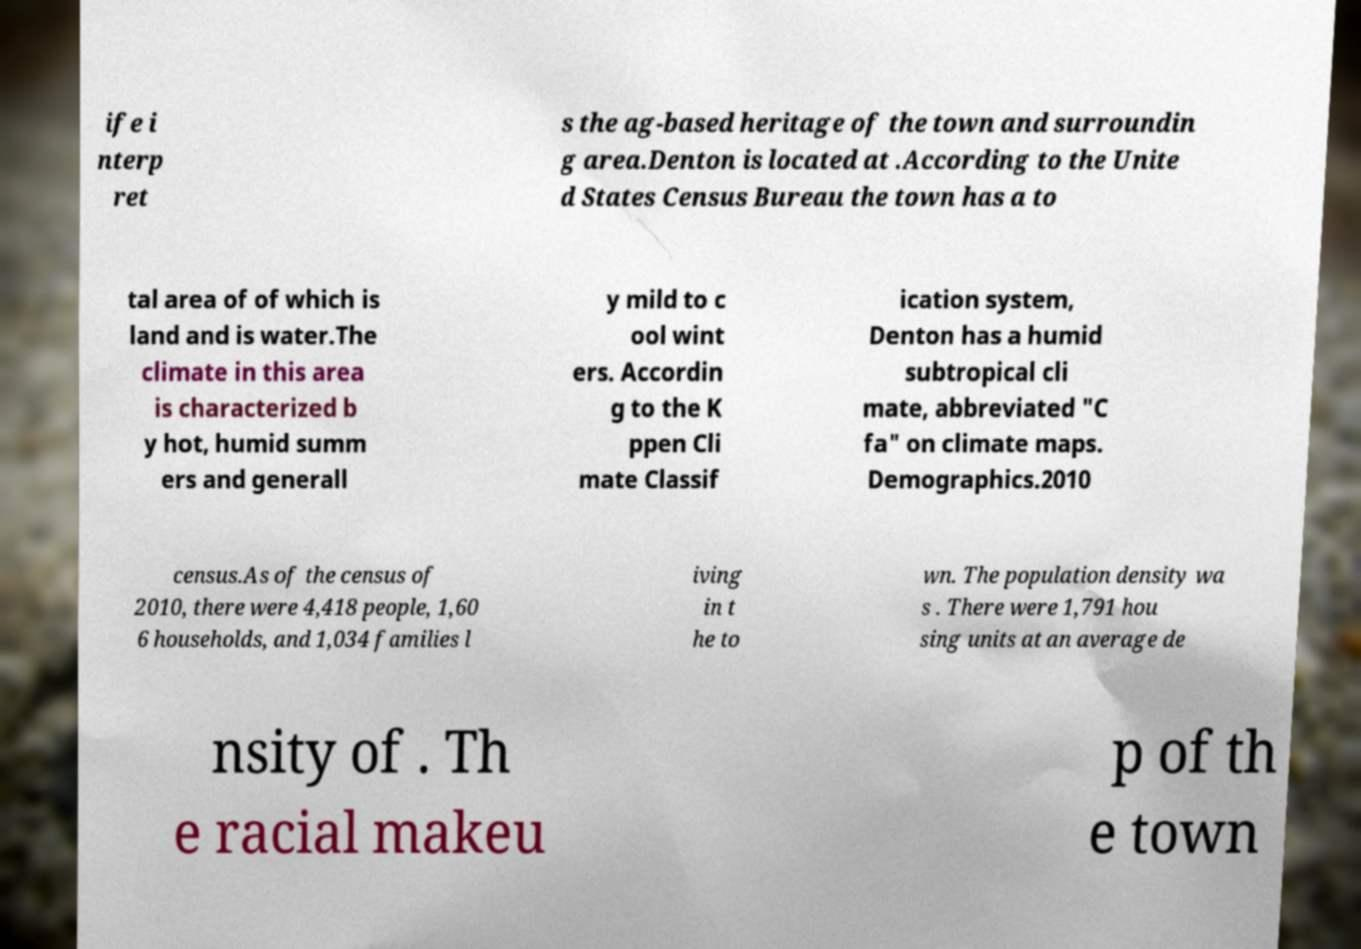There's text embedded in this image that I need extracted. Can you transcribe it verbatim? ife i nterp ret s the ag-based heritage of the town and surroundin g area.Denton is located at .According to the Unite d States Census Bureau the town has a to tal area of of which is land and is water.The climate in this area is characterized b y hot, humid summ ers and generall y mild to c ool wint ers. Accordin g to the K ppen Cli mate Classif ication system, Denton has a humid subtropical cli mate, abbreviated "C fa" on climate maps. Demographics.2010 census.As of the census of 2010, there were 4,418 people, 1,60 6 households, and 1,034 families l iving in t he to wn. The population density wa s . There were 1,791 hou sing units at an average de nsity of . Th e racial makeu p of th e town 